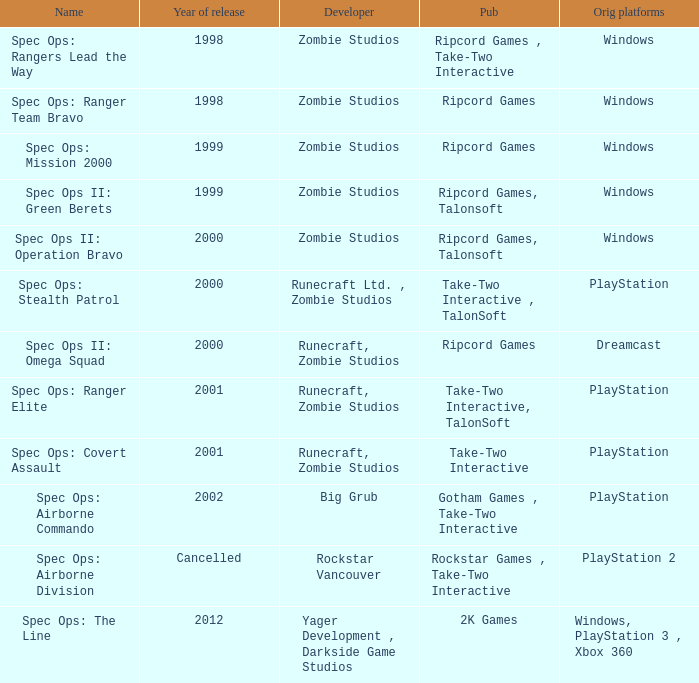Give me the full table as a dictionary. {'header': ['Name', 'Year of release', 'Developer', 'Pub', 'Orig platforms'], 'rows': [['Spec Ops: Rangers Lead the Way', '1998', 'Zombie Studios', 'Ripcord Games , Take-Two Interactive', 'Windows'], ['Spec Ops: Ranger Team Bravo', '1998', 'Zombie Studios', 'Ripcord Games', 'Windows'], ['Spec Ops: Mission 2000', '1999', 'Zombie Studios', 'Ripcord Games', 'Windows'], ['Spec Ops II: Green Berets', '1999', 'Zombie Studios', 'Ripcord Games, Talonsoft', 'Windows'], ['Spec Ops II: Operation Bravo', '2000', 'Zombie Studios', 'Ripcord Games, Talonsoft', 'Windows'], ['Spec Ops: Stealth Patrol', '2000', 'Runecraft Ltd. , Zombie Studios', 'Take-Two Interactive , TalonSoft', 'PlayStation'], ['Spec Ops II: Omega Squad', '2000', 'Runecraft, Zombie Studios', 'Ripcord Games', 'Dreamcast'], ['Spec Ops: Ranger Elite', '2001', 'Runecraft, Zombie Studios', 'Take-Two Interactive, TalonSoft', 'PlayStation'], ['Spec Ops: Covert Assault', '2001', 'Runecraft, Zombie Studios', 'Take-Two Interactive', 'PlayStation'], ['Spec Ops: Airborne Commando', '2002', 'Big Grub', 'Gotham Games , Take-Two Interactive', 'PlayStation'], ['Spec Ops: Airborne Division', 'Cancelled', 'Rockstar Vancouver', 'Rockstar Games , Take-Two Interactive', 'PlayStation 2'], ['Spec Ops: The Line', '2012', 'Yager Development , Darkside Game Studios', '2K Games', 'Windows, PlayStation 3 , Xbox 360']]} Which programmer has a year of abandoned launches? Rockstar Vancouver. 